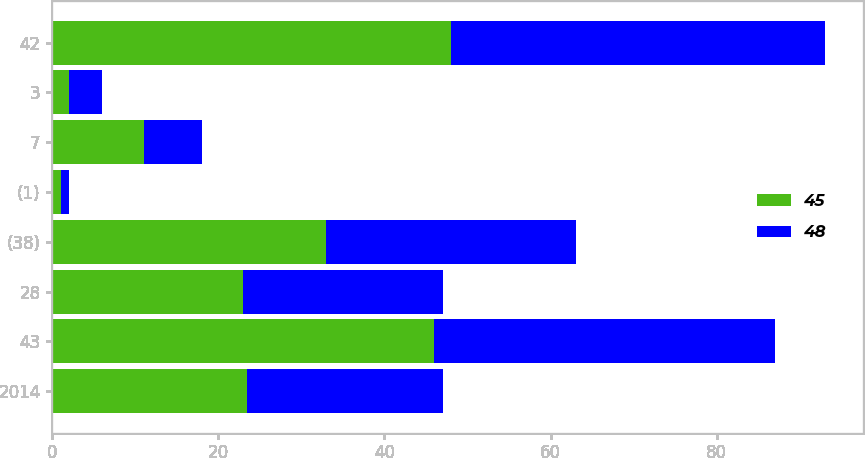Convert chart. <chart><loc_0><loc_0><loc_500><loc_500><stacked_bar_chart><ecel><fcel>2014<fcel>43<fcel>28<fcel>(38)<fcel>(1)<fcel>7<fcel>3<fcel>42<nl><fcel>45<fcel>23.5<fcel>46<fcel>23<fcel>33<fcel>1<fcel>11<fcel>2<fcel>48<nl><fcel>48<fcel>23.5<fcel>41<fcel>24<fcel>30<fcel>1<fcel>7<fcel>4<fcel>45<nl></chart> 